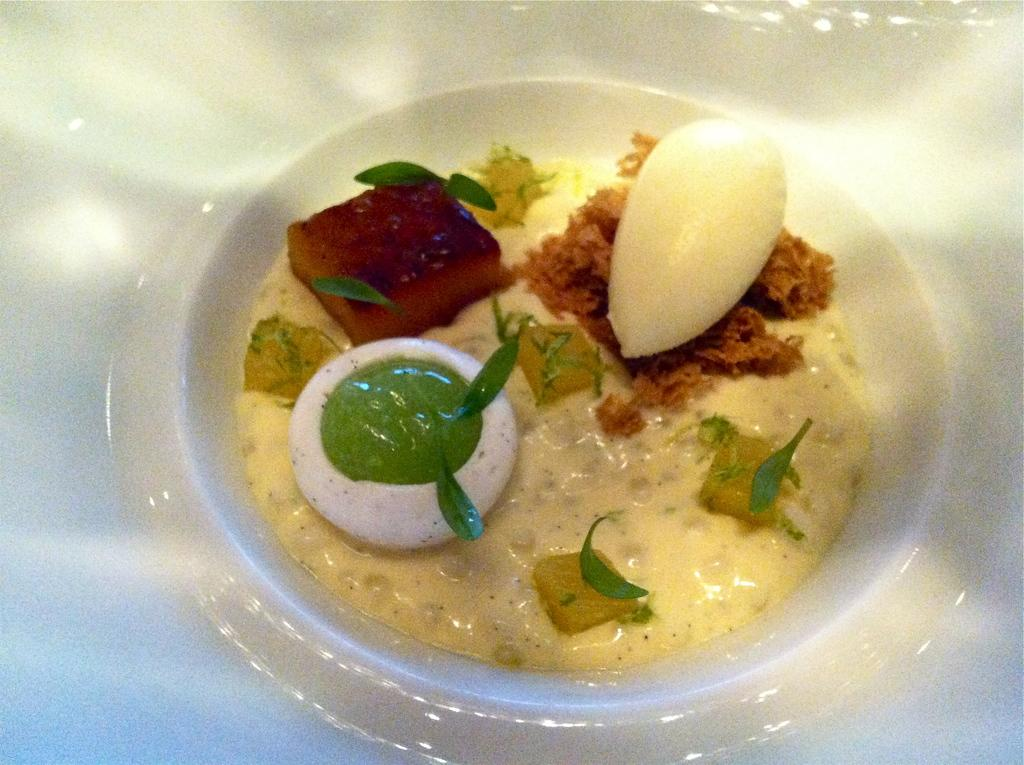What is present in the image related to food? There are food items in the image. How are the food items arranged or displayed? The food items are in a plate. What is the rate of sugar consumption in the image? There is no information about sugar consumption in the image, as it only shows food items in a plate. 